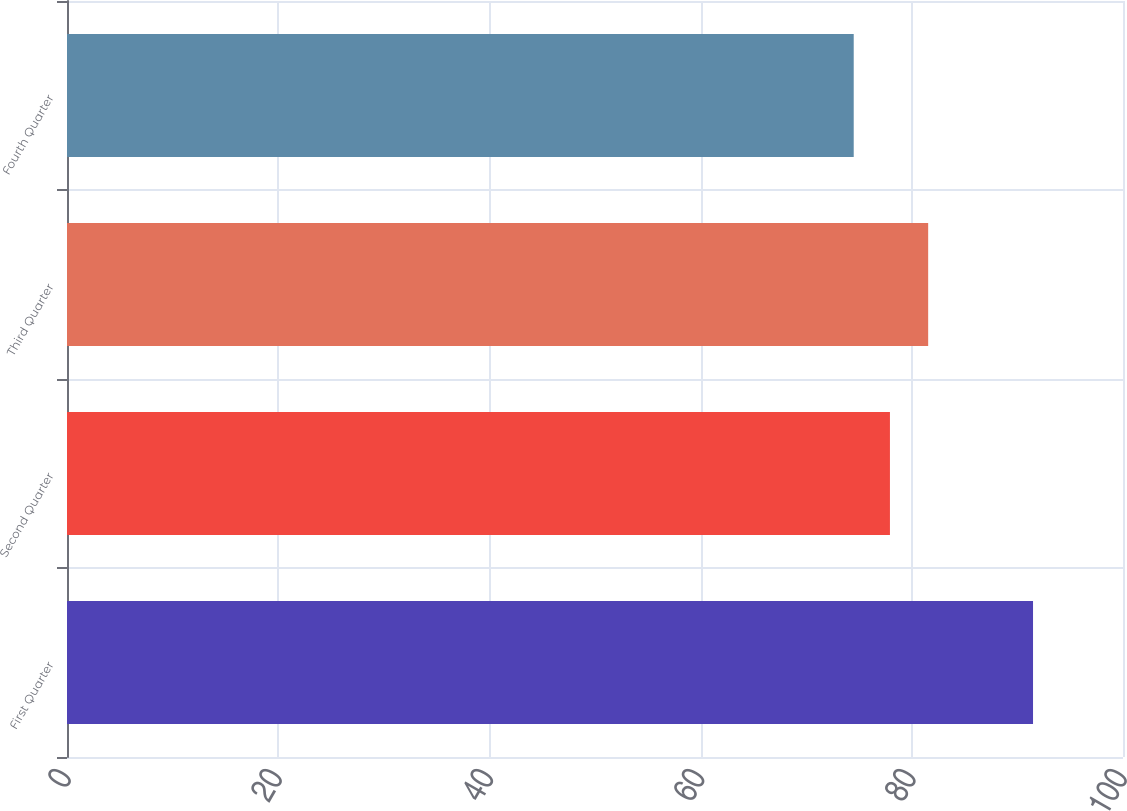<chart> <loc_0><loc_0><loc_500><loc_500><bar_chart><fcel>First Quarter<fcel>Second Quarter<fcel>Third Quarter<fcel>Fourth Quarter<nl><fcel>91.48<fcel>77.93<fcel>81.55<fcel>74.5<nl></chart> 